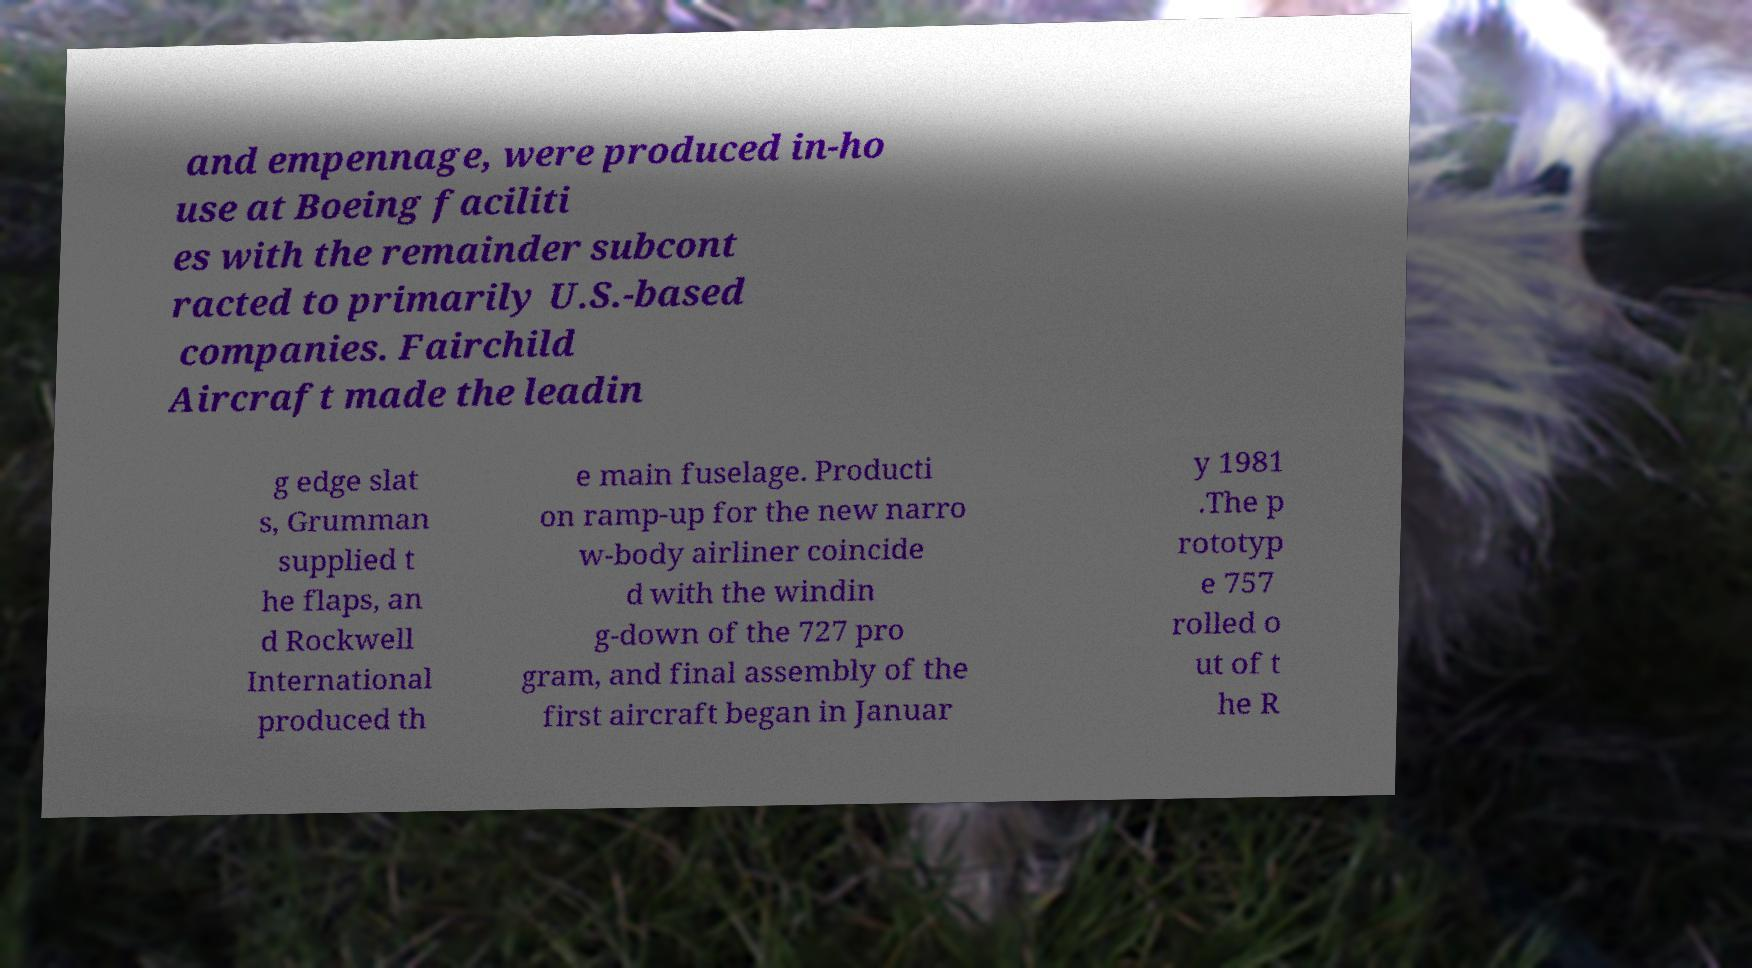Can you read and provide the text displayed in the image?This photo seems to have some interesting text. Can you extract and type it out for me? and empennage, were produced in-ho use at Boeing faciliti es with the remainder subcont racted to primarily U.S.-based companies. Fairchild Aircraft made the leadin g edge slat s, Grumman supplied t he flaps, an d Rockwell International produced th e main fuselage. Producti on ramp-up for the new narro w-body airliner coincide d with the windin g-down of the 727 pro gram, and final assembly of the first aircraft began in Januar y 1981 .The p rototyp e 757 rolled o ut of t he R 